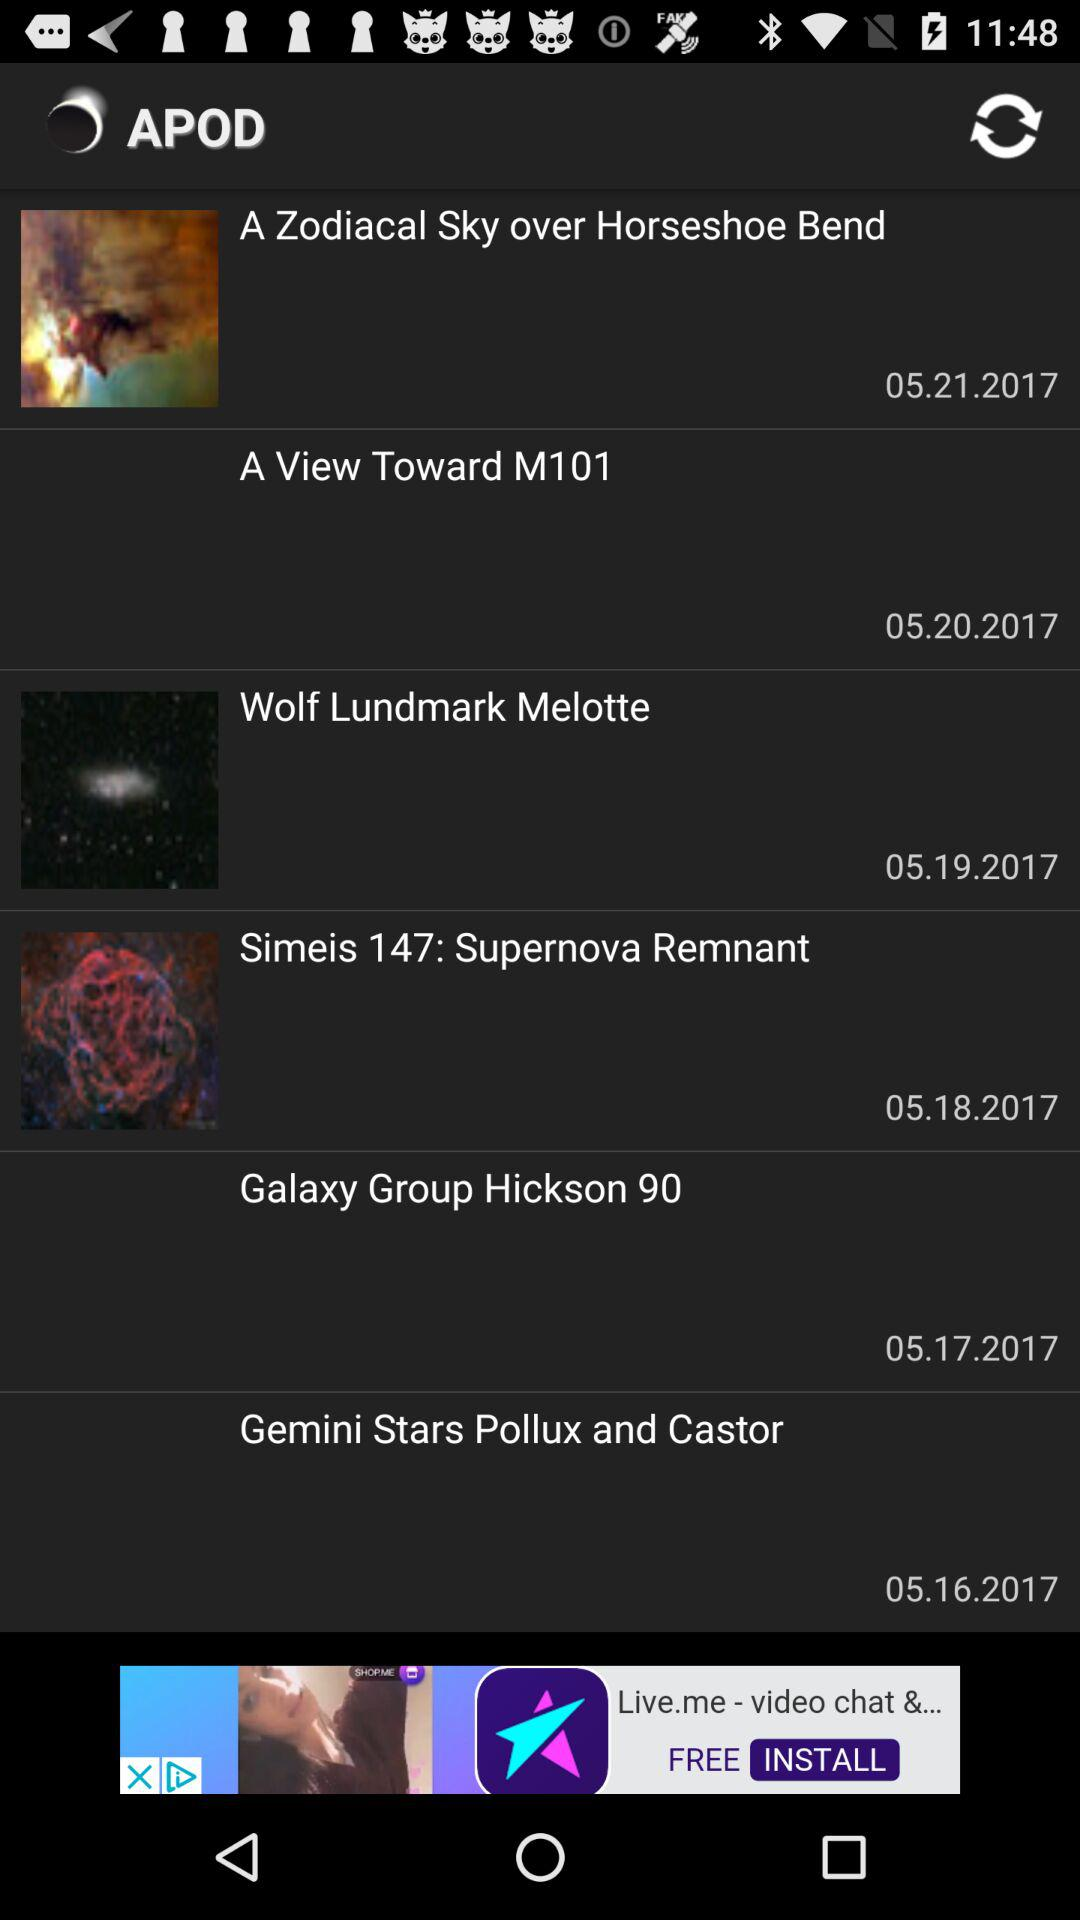What is the duration of "Wolf Lundmark Melotte"?
When the provided information is insufficient, respond with <no answer>. <no answer> 